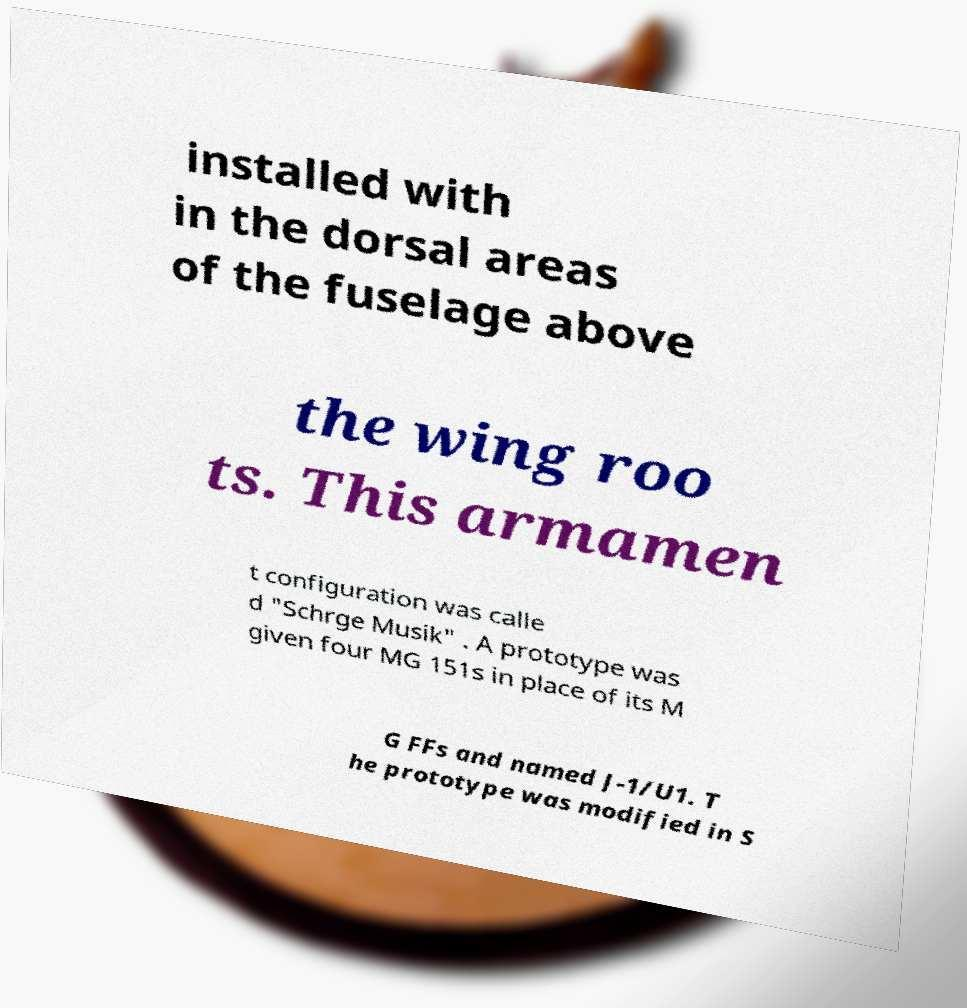What messages or text are displayed in this image? I need them in a readable, typed format. installed with in the dorsal areas of the fuselage above the wing roo ts. This armamen t configuration was calle d "Schrge Musik" . A prototype was given four MG 151s in place of its M G FFs and named J-1/U1. T he prototype was modified in S 